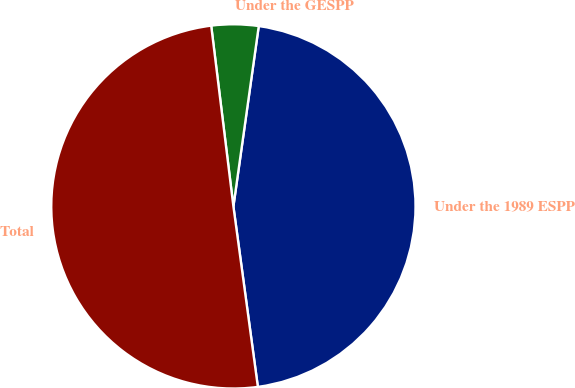Convert chart. <chart><loc_0><loc_0><loc_500><loc_500><pie_chart><fcel>Under the 1989 ESPP<fcel>Under the GESPP<fcel>Total<nl><fcel>45.63%<fcel>4.17%<fcel>50.2%<nl></chart> 